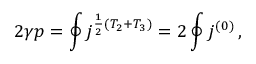Convert formula to latex. <formula><loc_0><loc_0><loc_500><loc_500>2 \gamma p = \oint j ^ { \frac { 1 } { 2 } ( T _ { 2 } + T _ { 3 } ) } = 2 \oint j ^ { ( 0 ) } \, ,</formula> 